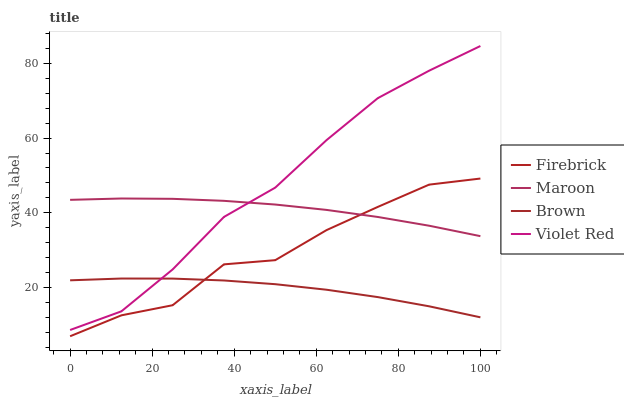Does Brown have the minimum area under the curve?
Answer yes or no. Yes. Does Violet Red have the maximum area under the curve?
Answer yes or no. Yes. Does Firebrick have the minimum area under the curve?
Answer yes or no. No. Does Firebrick have the maximum area under the curve?
Answer yes or no. No. Is Maroon the smoothest?
Answer yes or no. Yes. Is Firebrick the roughest?
Answer yes or no. Yes. Is Violet Red the smoothest?
Answer yes or no. No. Is Violet Red the roughest?
Answer yes or no. No. Does Firebrick have the lowest value?
Answer yes or no. Yes. Does Violet Red have the lowest value?
Answer yes or no. No. Does Violet Red have the highest value?
Answer yes or no. Yes. Does Firebrick have the highest value?
Answer yes or no. No. Is Firebrick less than Violet Red?
Answer yes or no. Yes. Is Violet Red greater than Firebrick?
Answer yes or no. Yes. Does Brown intersect Firebrick?
Answer yes or no. Yes. Is Brown less than Firebrick?
Answer yes or no. No. Is Brown greater than Firebrick?
Answer yes or no. No. Does Firebrick intersect Violet Red?
Answer yes or no. No. 